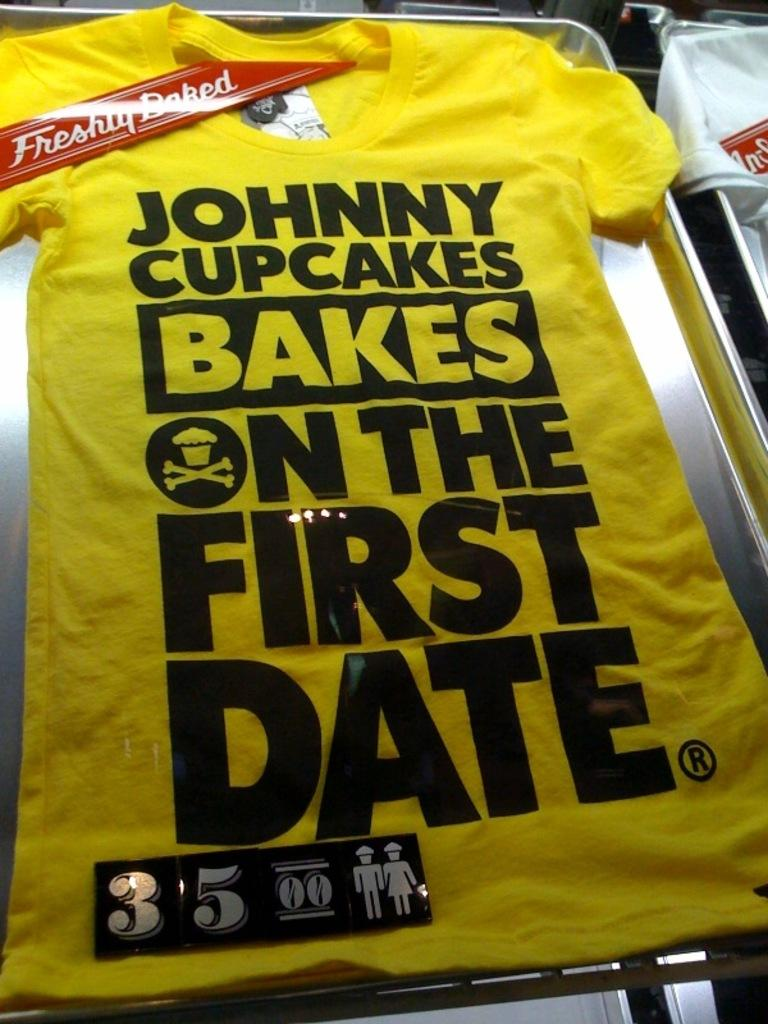<image>
Render a clear and concise summary of the photo. A yellow shirt says that Johnny Cupcakes bakes on the first date. 